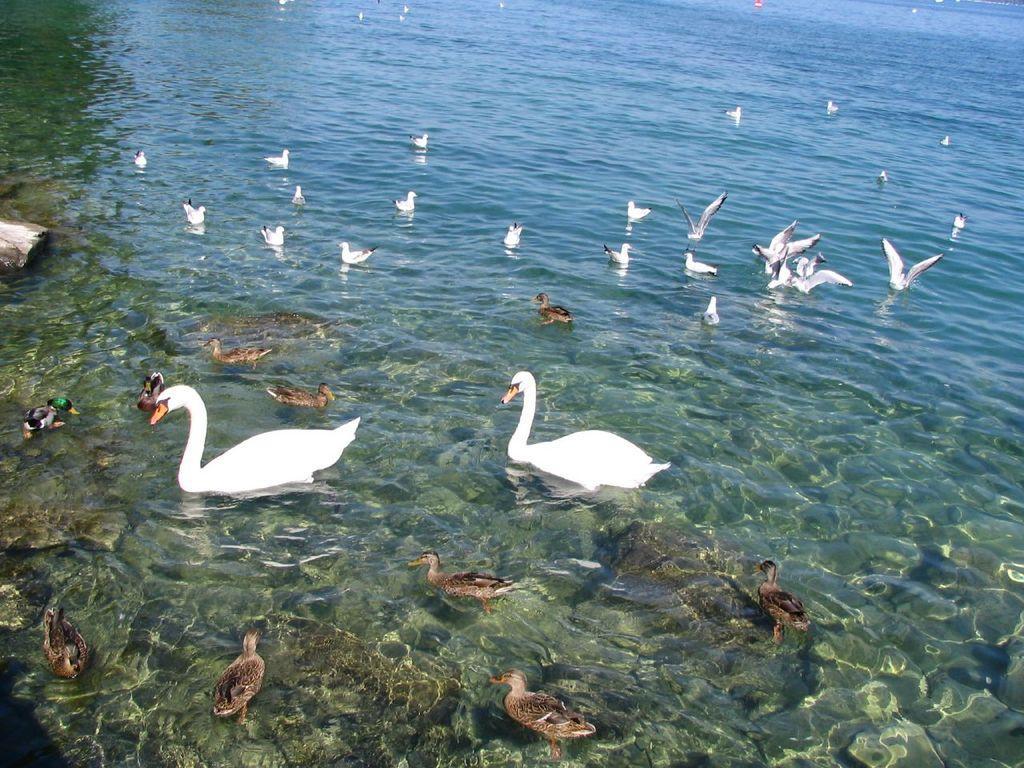Can you describe this image briefly? In this image, we can see some birds and swans in the water. 